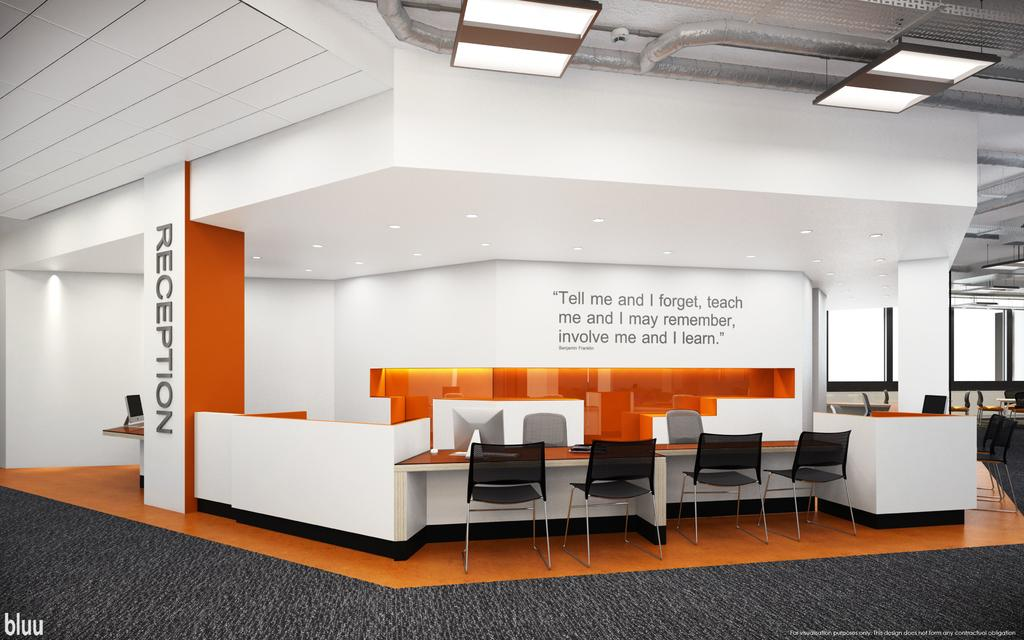What type of furniture is visible in the image? There are chairs and tables in the image. What can be seen hanging from the ceiling in the image? There are lights in the image. What type of text is present on the wall in the image? There are words on the wall in the image. What type of text is present on a pillar in the image? There are words on a pillar in the image. What type of imperfections are present on the image itself? There are watermarks on the image. What is the price of the animal in the image? There is no animal present in the image, so there is no price to consider. What type of order is being placed in the image? There is no indication of an order being placed in the image. 